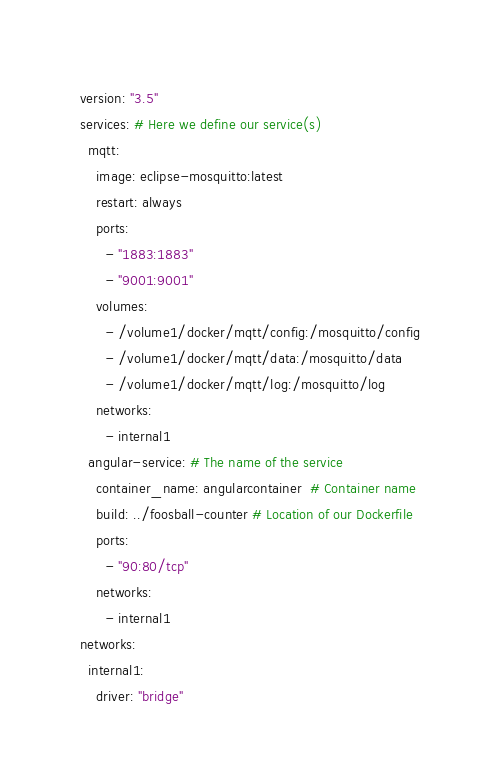Convert code to text. <code><loc_0><loc_0><loc_500><loc_500><_YAML_>version: "3.5"
services: # Here we define our service(s)
  mqtt:
    image: eclipse-mosquitto:latest
    restart: always
    ports:
      - "1883:1883"
      - "9001:9001"
    volumes:
      - /volume1/docker/mqtt/config:/mosquitto/config
      - /volume1/docker/mqtt/data:/mosquitto/data
      - /volume1/docker/mqtt/log:/mosquitto/log
    networks:
      - internal1
  angular-service: # The name of the service
    container_name: angularcontainer  # Container name
    build: ../foosball-counter # Location of our Dockerfile
    ports:
      - "90:80/tcp"
    networks:
      - internal1
networks:
  internal1:
    driver: "bridge"
</code> 